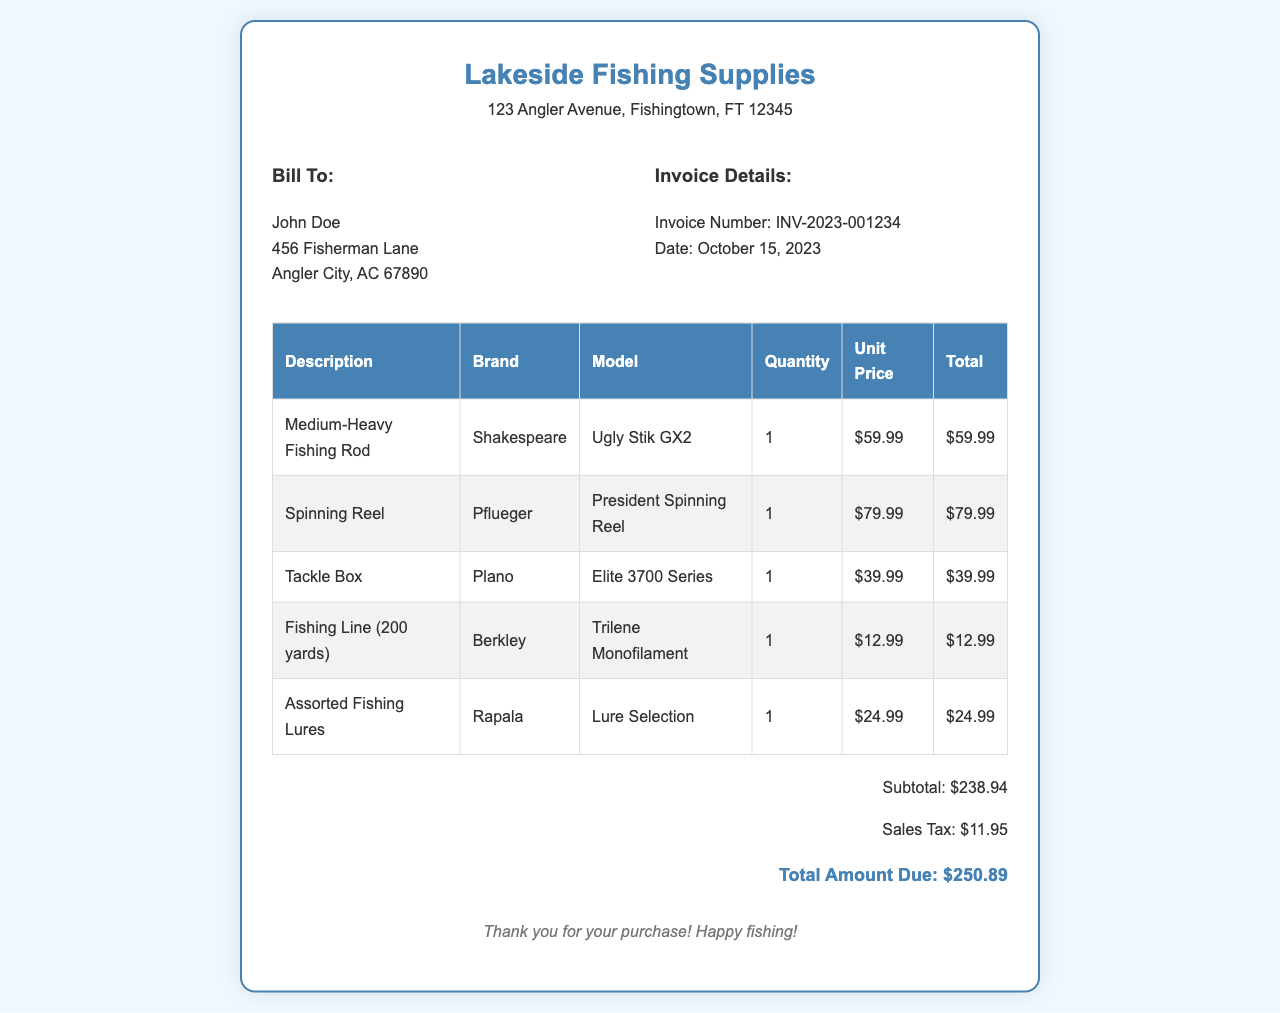What is the store name? The store name is listed at the top of the invoice.
Answer: Lakeside Fishing Supplies Who is the bill to? The bill to section contains the name and address of the customer.
Answer: John Doe What is the invoice number? The invoice number is mentioned in the invoice details section.
Answer: INV-2023-001234 How many fishing rods were purchased? The quantity column indicates the number of fishing rods purchased.
Answer: 1 What is the total amount due? The total amount due is calculated from the subtotal and sales tax at the end of the invoice.
Answer: $250.89 What is the sales tax amount? The sales tax is listed separately in the total section.
Answer: $11.95 What brand is the spinning reel? The brand of the spinning reel is listed in the product details of the invoice.
Answer: Pflueger Which tackle box model was bought? The model name is specified in the table of purchases.
Answer: Elite 3700 Series What is the subtotal amount? The subtotal amount is provided before the sales tax in the total section.
Answer: $238.94 